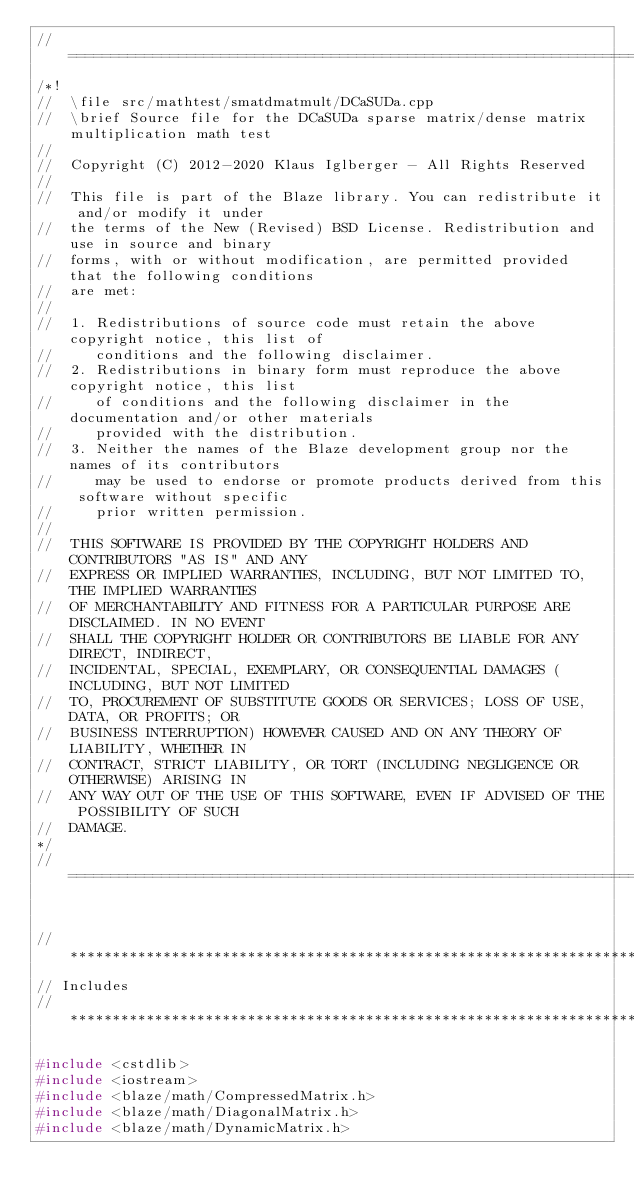<code> <loc_0><loc_0><loc_500><loc_500><_C++_>//=================================================================================================
/*!
//  \file src/mathtest/smatdmatmult/DCaSUDa.cpp
//  \brief Source file for the DCaSUDa sparse matrix/dense matrix multiplication math test
//
//  Copyright (C) 2012-2020 Klaus Iglberger - All Rights Reserved
//
//  This file is part of the Blaze library. You can redistribute it and/or modify it under
//  the terms of the New (Revised) BSD License. Redistribution and use in source and binary
//  forms, with or without modification, are permitted provided that the following conditions
//  are met:
//
//  1. Redistributions of source code must retain the above copyright notice, this list of
//     conditions and the following disclaimer.
//  2. Redistributions in binary form must reproduce the above copyright notice, this list
//     of conditions and the following disclaimer in the documentation and/or other materials
//     provided with the distribution.
//  3. Neither the names of the Blaze development group nor the names of its contributors
//     may be used to endorse or promote products derived from this software without specific
//     prior written permission.
//
//  THIS SOFTWARE IS PROVIDED BY THE COPYRIGHT HOLDERS AND CONTRIBUTORS "AS IS" AND ANY
//  EXPRESS OR IMPLIED WARRANTIES, INCLUDING, BUT NOT LIMITED TO, THE IMPLIED WARRANTIES
//  OF MERCHANTABILITY AND FITNESS FOR A PARTICULAR PURPOSE ARE DISCLAIMED. IN NO EVENT
//  SHALL THE COPYRIGHT HOLDER OR CONTRIBUTORS BE LIABLE FOR ANY DIRECT, INDIRECT,
//  INCIDENTAL, SPECIAL, EXEMPLARY, OR CONSEQUENTIAL DAMAGES (INCLUDING, BUT NOT LIMITED
//  TO, PROCUREMENT OF SUBSTITUTE GOODS OR SERVICES; LOSS OF USE, DATA, OR PROFITS; OR
//  BUSINESS INTERRUPTION) HOWEVER CAUSED AND ON ANY THEORY OF LIABILITY, WHETHER IN
//  CONTRACT, STRICT LIABILITY, OR TORT (INCLUDING NEGLIGENCE OR OTHERWISE) ARISING IN
//  ANY WAY OUT OF THE USE OF THIS SOFTWARE, EVEN IF ADVISED OF THE POSSIBILITY OF SUCH
//  DAMAGE.
*/
//=================================================================================================


//*************************************************************************************************
// Includes
//*************************************************************************************************

#include <cstdlib>
#include <iostream>
#include <blaze/math/CompressedMatrix.h>
#include <blaze/math/DiagonalMatrix.h>
#include <blaze/math/DynamicMatrix.h></code> 